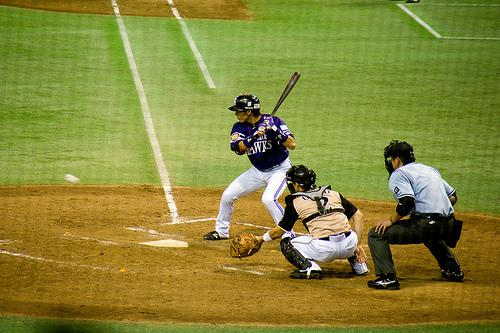Question: who is holding a bat?
Choices:
A. The batter.
B. Club owner.
C. Girl.
D. Coach.
Answer with the letter. Answer: A Question: who is wearing a glove?
Choices:
A. Player.
B. Hind Catcher.
C. Coach.
D. Umpire.
Answer with the letter. Answer: B Question: what color is the hind catchers glove?
Choices:
A. White.
B. Black.
C. Brown.
D. Gray.
Answer with the letter. Answer: C Question: what color is the grass on the field?
Choices:
A. Brown.
B. Gray.
C. Yellow.
D. Green.
Answer with the letter. Answer: D Question: what game is being played?
Choices:
A. Baseball.
B. Soccer.
C. Basketball.
D. Hockey.
Answer with the letter. Answer: A Question: what kind of field are they playing on?
Choices:
A. Soccer.
B. Softball.
C. Football.
D. Baseball field.
Answer with the letter. Answer: D 